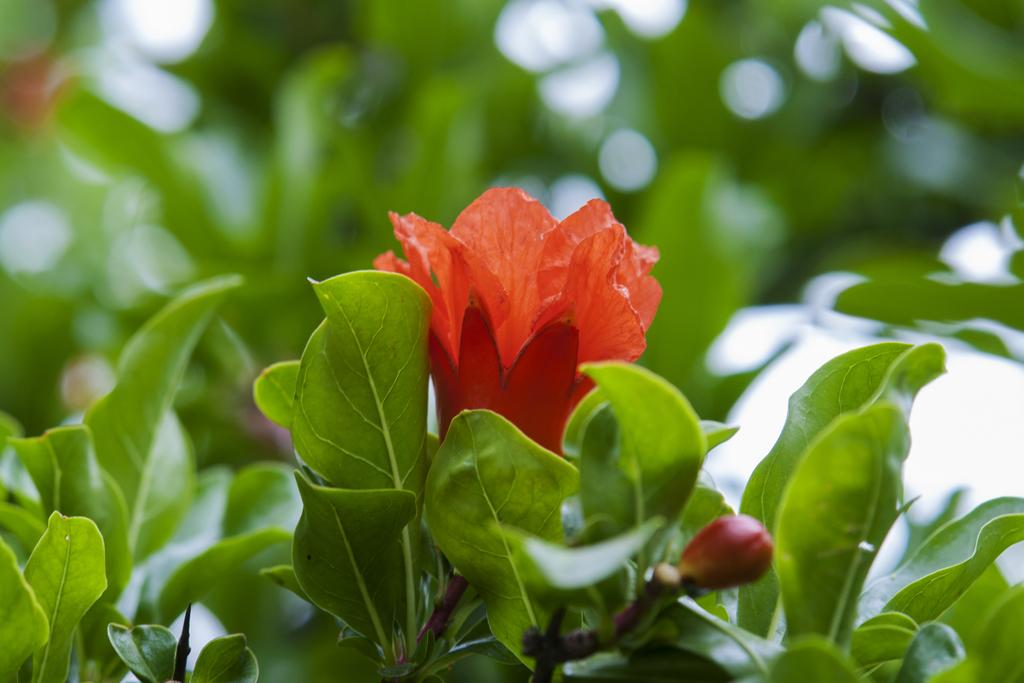What is the main subject of the image? There is a flower in the image. Can you describe the flower's position in the image? The flower is on the stem of a plant. What else can be seen in the background of the image? There is a group of leaves in the background of the image. How does the flower jump in the image? The flower does not jump in the image; it is stationary on the stem of the plant. What type of hair can be seen on the flower in the image? There is no hair present on the flower in the image, as flowers do not have hair. 